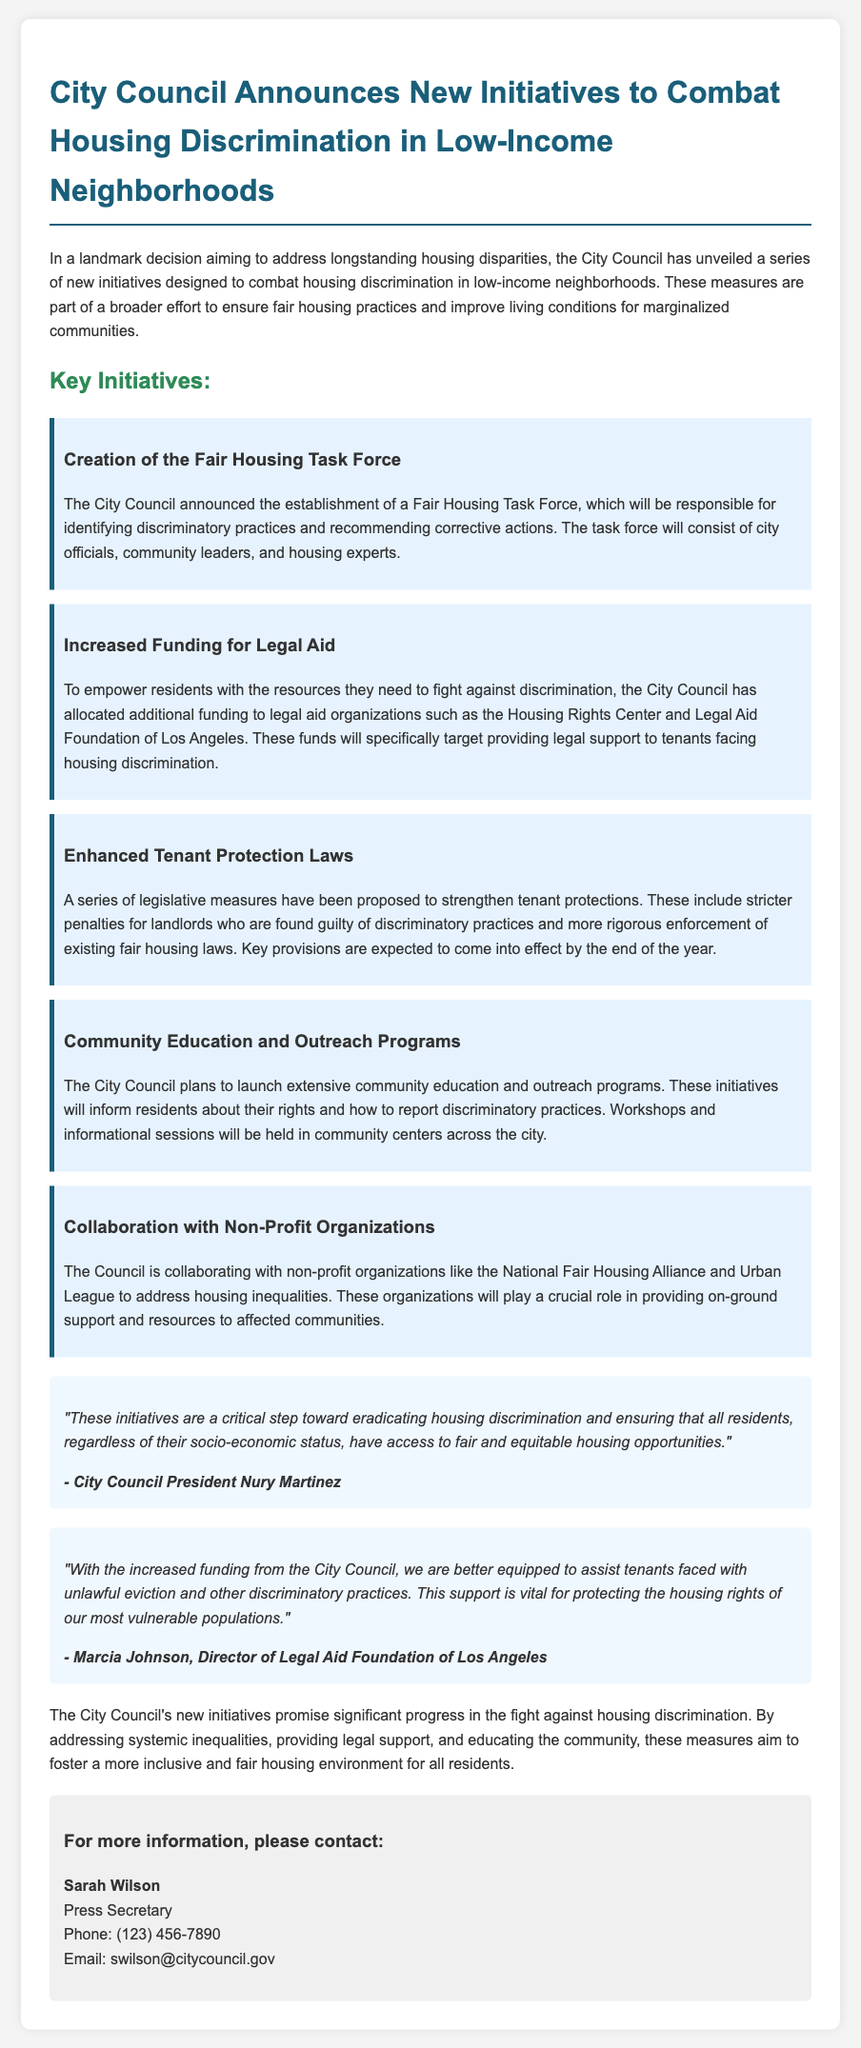What is the name of the task force created by the City Council? The task force announced is called the Fair Housing Task Force.
Answer: Fair Housing Task Force Who is the Director of the Legal Aid Foundation of Los Angeles? The Director mentioned in the document is Marcia Johnson.
Answer: Marcia Johnson What key initiative involves legal support for tenants? The initiative that focuses on legal support is the Increased Funding for Legal Aid.
Answer: Increased Funding for Legal Aid Which organization is collaborating with the Council to address housing inequalities? The document mentions collaboration with the National Fair Housing Alliance.
Answer: National Fair Housing Alliance What is one of the proposed enhancements to tenant protection laws? The document states there will be stricter penalties for landlords found guilty of discriminatory practices.
Answer: Stricter penalties How does the City Council plan to educate residents about their housing rights? The City Council plans to launch extensive community education and outreach programs.
Answer: Community education and outreach programs What is a critical step mentioned in the document for combating housing discrimination? The City Council's initiatives are described as a critical step toward eradicating housing discrimination.
Answer: Critical step When are key provisions of the tenant protections expected to come into effect? Key provisions are expected to come into effect by the end of the year.
Answer: End of the year 